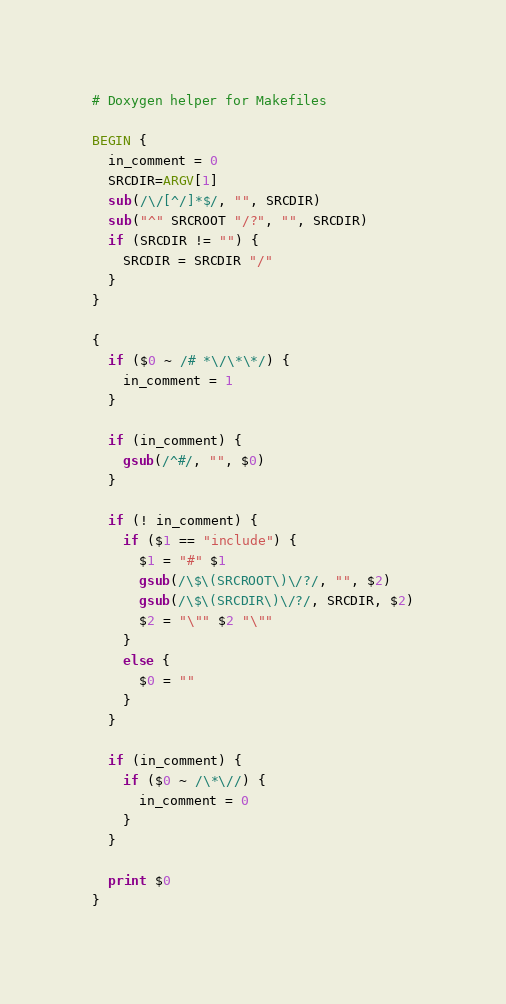<code> <loc_0><loc_0><loc_500><loc_500><_Awk_># Doxygen helper for Makefiles

BEGIN {
  in_comment = 0
  SRCDIR=ARGV[1]
  sub(/\/[^/]*$/, "", SRCDIR)
  sub("^" SRCROOT "/?", "", SRCDIR)
  if (SRCDIR != "") {
    SRCDIR = SRCDIR "/"
  }
}

{
  if ($0 ~ /# *\/\*\*/) {
    in_comment = 1
  }

  if (in_comment) {
    gsub(/^#/, "", $0)
  }

  if (! in_comment) {
    if ($1 == "include") {
      $1 = "#" $1
      gsub(/\$\(SRCROOT\)\/?/, "", $2)
      gsub(/\$\(SRCDIR\)\/?/, SRCDIR, $2)
      $2 = "\"" $2 "\""
    }
    else {
      $0 = ""
    }
  }

  if (in_comment) {
    if ($0 ~ /\*\//) {
      in_comment = 0
    }
  }

  print $0
}
</code> 